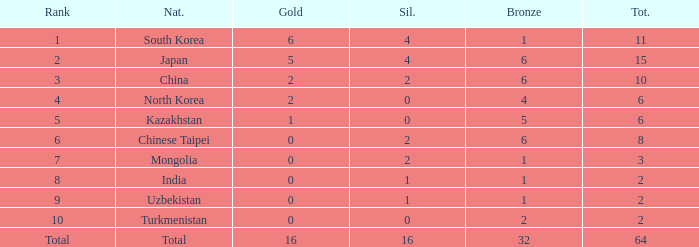What is the total Gold's less than 0? 0.0. 